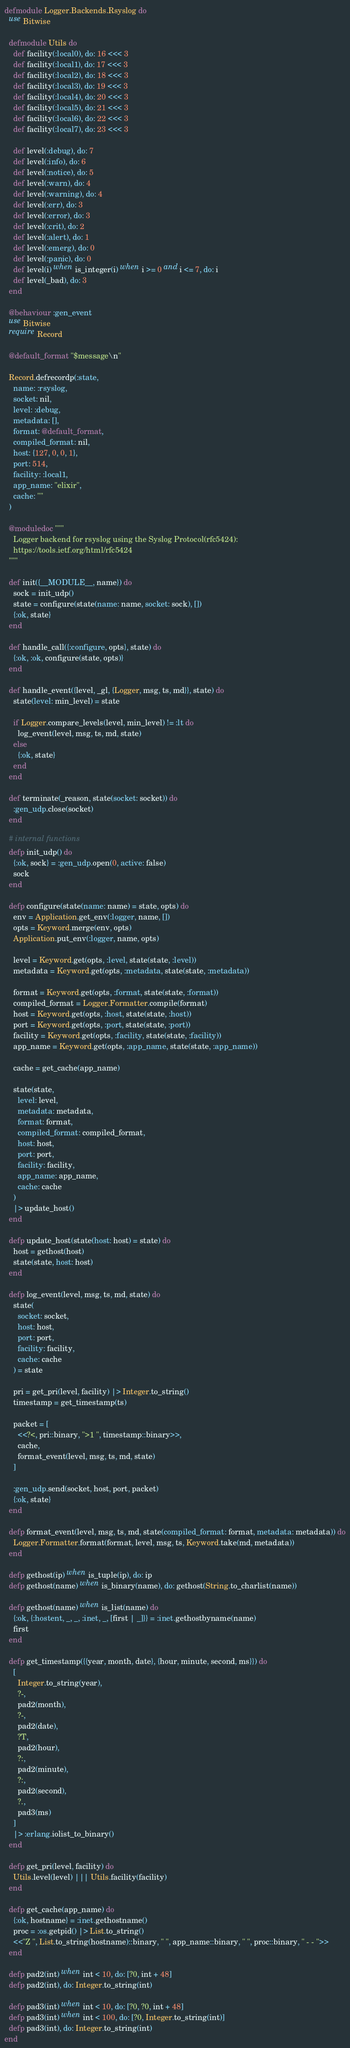<code> <loc_0><loc_0><loc_500><loc_500><_Elixir_>defmodule Logger.Backends.Rsyslog do
  use Bitwise

  defmodule Utils do
    def facility(:local0), do: 16 <<< 3
    def facility(:local1), do: 17 <<< 3
    def facility(:local2), do: 18 <<< 3
    def facility(:local3), do: 19 <<< 3
    def facility(:local4), do: 20 <<< 3
    def facility(:local5), do: 21 <<< 3
    def facility(:local6), do: 22 <<< 3
    def facility(:local7), do: 23 <<< 3

    def level(:debug), do: 7
    def level(:info), do: 6
    def level(:notice), do: 5
    def level(:warn), do: 4
    def level(:warning), do: 4
    def level(:err), do: 3
    def level(:error), do: 3
    def level(:crit), do: 2
    def level(:alert), do: 1
    def level(:emerg), do: 0
    def level(:panic), do: 0
    def level(i) when is_integer(i) when i >= 0 and i <= 7, do: i
    def level(_bad), do: 3
  end

  @behaviour :gen_event
  use Bitwise
  require Record

  @default_format "$message\n"

  Record.defrecordp(:state,
    name: :rsyslog,
    socket: nil,
    level: :debug,
    metadata: [],
    format: @default_format,
    compiled_format: nil,
    host: {127, 0, 0, 1},
    port: 514,
    facility: :local1,
    app_name: "elixir",
    cache: ""
  )

  @moduledoc """
    Logger backend for rsyslog using the Syslog Protocol(rfc5424):
    https://tools.ietf.org/html/rfc5424
  """

  def init({__MODULE__, name}) do
    sock = init_udp()
    state = configure(state(name: name, socket: sock), [])
    {:ok, state}
  end

  def handle_call({:configure, opts}, state) do
    {:ok, :ok, configure(state, opts)}
  end

  def handle_event({level, _gl, {Logger, msg, ts, md}}, state) do
    state(level: min_level) = state

    if Logger.compare_levels(level, min_level) != :lt do
      log_event(level, msg, ts, md, state)
    else
      {:ok, state}
    end
  end

  def terminate(_reason, state(socket: socket)) do
    :gen_udp.close(socket)
  end

  # internal functions
  defp init_udp() do
    {:ok, sock} = :gen_udp.open(0, active: false)
    sock
  end

  defp configure(state(name: name) = state, opts) do
    env = Application.get_env(:logger, name, [])
    opts = Keyword.merge(env, opts)
    Application.put_env(:logger, name, opts)

    level = Keyword.get(opts, :level, state(state, :level))
    metadata = Keyword.get(opts, :metadata, state(state, :metadata))

    format = Keyword.get(opts, :format, state(state, :format))
    compiled_format = Logger.Formatter.compile(format)
    host = Keyword.get(opts, :host, state(state, :host))
    port = Keyword.get(opts, :port, state(state, :port))
    facility = Keyword.get(opts, :facility, state(state, :facility))
    app_name = Keyword.get(opts, :app_name, state(state, :app_name))

    cache = get_cache(app_name)

    state(state,
      level: level,
      metadata: metadata,
      format: format,
      compiled_format: compiled_format,
      host: host,
      port: port,
      facility: facility,
      app_name: app_name,
      cache: cache
    )
    |> update_host()
  end

  defp update_host(state(host: host) = state) do
    host = gethost(host)
    state(state, host: host)
  end

  defp log_event(level, msg, ts, md, state) do
    state(
      socket: socket,
      host: host,
      port: port,
      facility: facility,
      cache: cache
    ) = state

    pri = get_pri(level, facility) |> Integer.to_string()
    timestamp = get_timestamp(ts)

    packet = [
      <<?<, pri::binary, ">1 ", timestamp::binary>>,
      cache,
      format_event(level, msg, ts, md, state)
    ]

    :gen_udp.send(socket, host, port, packet)
    {:ok, state}
  end

  defp format_event(level, msg, ts, md, state(compiled_format: format, metadata: metadata)) do
    Logger.Formatter.format(format, level, msg, ts, Keyword.take(md, metadata))
  end

  defp gethost(ip) when is_tuple(ip), do: ip
  defp gethost(name) when is_binary(name), do: gethost(String.to_charlist(name))

  defp gethost(name) when is_list(name) do
    {:ok, {:hostent, _, _, :inet, _, [first | _]}} = :inet.gethostbyname(name)
    first
  end

  defp get_timestamp({{year, month, date}, {hour, minute, second, ms}}) do
    [
      Integer.to_string(year),
      ?-,
      pad2(month),
      ?-,
      pad2(date),
      ?T,
      pad2(hour),
      ?:,
      pad2(minute),
      ?:,
      pad2(second),
      ?.,
      pad3(ms)
    ]
    |> :erlang.iolist_to_binary()
  end

  defp get_pri(level, facility) do
    Utils.level(level) ||| Utils.facility(facility)
  end

  defp get_cache(app_name) do
    {:ok, hostname} = :inet.gethostname()
    proc = :os.getpid() |> List.to_string()
    <<"Z ", List.to_string(hostname)::binary, " ", app_name::binary, " ", proc::binary, " - - ">>
  end

  defp pad2(int) when int < 10, do: [?0, int + 48]
  defp pad2(int), do: Integer.to_string(int)

  defp pad3(int) when int < 10, do: [?0, ?0, int + 48]
  defp pad3(int) when int < 100, do: [?0, Integer.to_string(int)]
  defp pad3(int), do: Integer.to_string(int)
end
</code> 